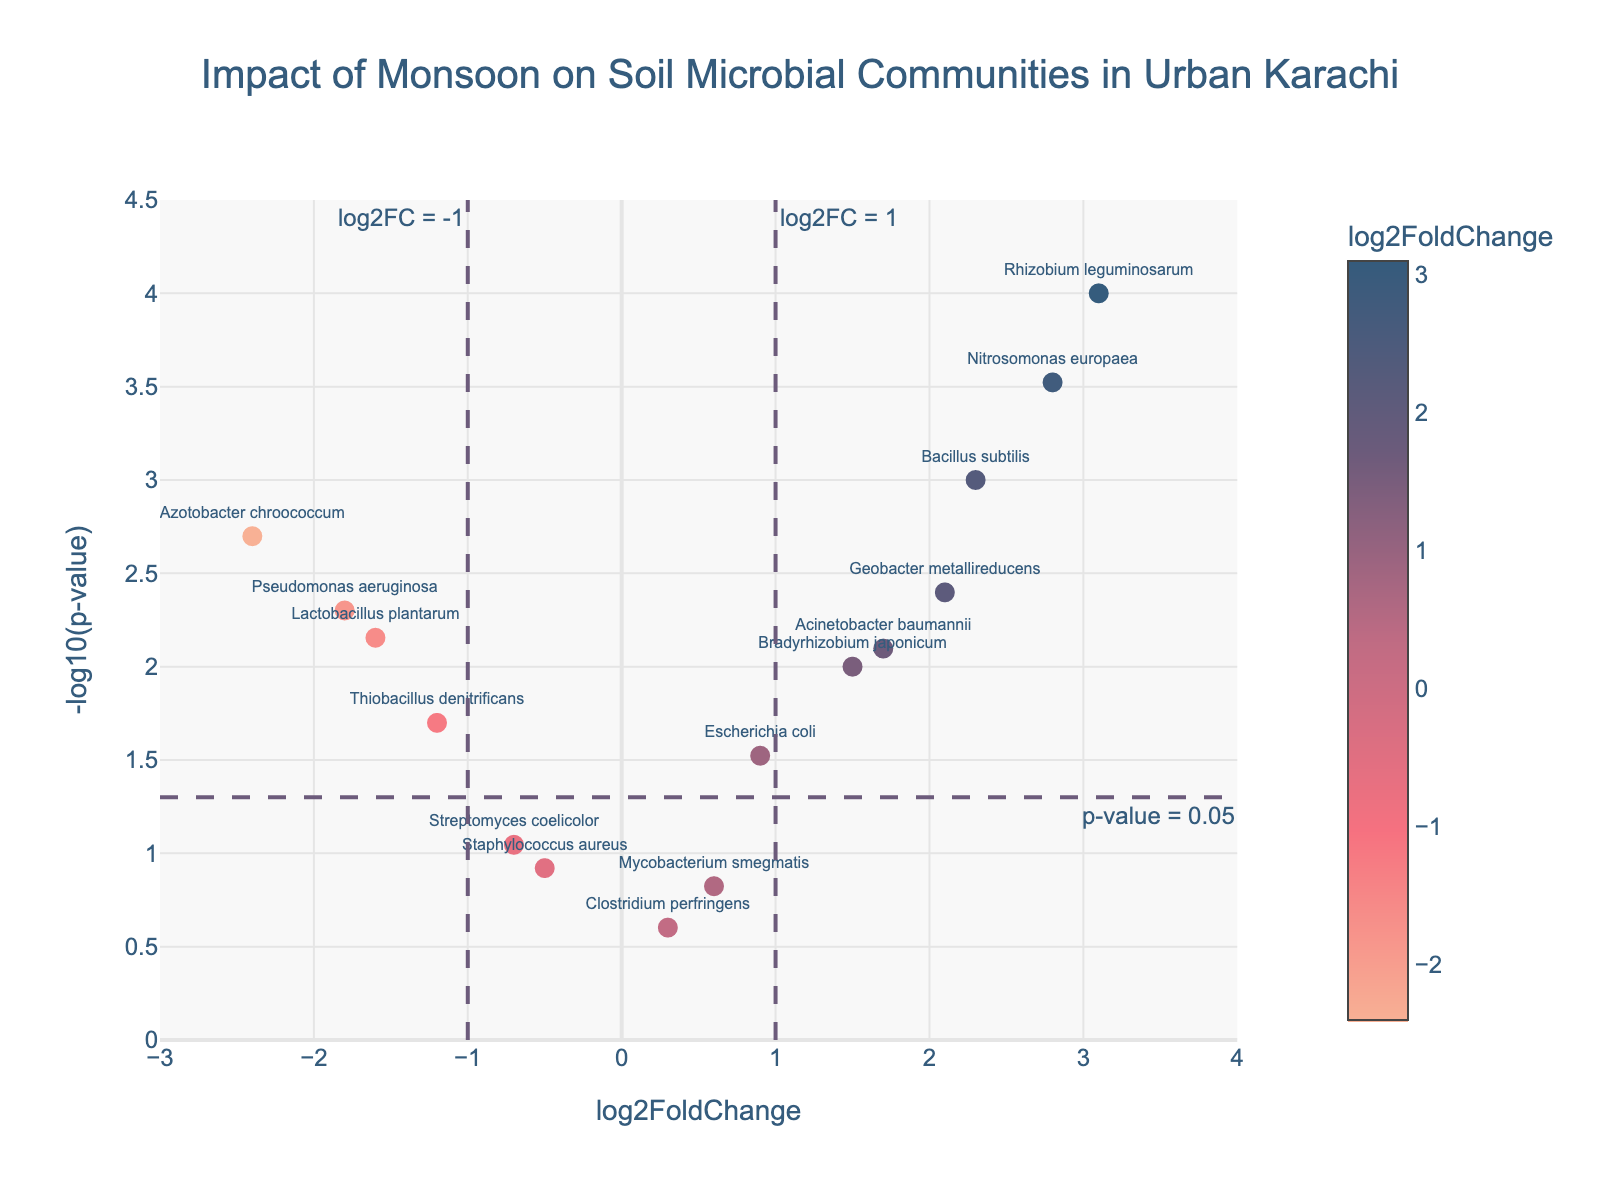What is the title of the plot? The title is displayed prominently at the top of the figure. It reads: "Impact of Monsoon on Soil Microbial Communities in Urban Karachi".
Answer: Impact of Monsoon on Soil Microbial Communities in Urban Karachi What does the x-axis represent in the plot? The x-axis is labeled at the bottom of the figure, which indicates that it represents "log2FoldChange".
Answer: log2FoldChange Which color in the plot represents the highest log2FoldChange? The color scale bar on the right side of the figure shows that darker shades represent higher log2FoldChange.
Answer: Darker shades represent higher log2FoldChange How many microbes have a log2FoldChange above 2? By inspecting the x-axis and counting the markers, we can see there are 4 microbes with log2FoldChange above 2.
Answer: 4 Which microbe has the highest -log10(p-value)? The topmost point on the y-axis represents the highest -log10(p-value), which is Rhizobium leguminosarum.
Answer: Rhizobium leguminosarum What is the log2FoldChange and p-value for Pseudomonas aeruginosa? Hovering over the relevant data point, the hover text shows "Pseudomonas aeruginosa<br>log2FC: -1.80<br>p-value: 0.0050".
Answer: log2FC: -1.80, p-value: 0.005 Which microbe shows a significant change with a p-value below 0.05 and a log2FoldChange greater than 1? Inspect the figure for data points with a y value above the dashed line corresponding to -log10(p-value) = 0.05 and x value greater than 1, which identifies Nitrosomonas europaea.
Answer: Nitrosomonas europaea What threshold values are indicated by dashed lines in the plot? The dashed lines mark threshold values at log2FC = 1 and log2FC = -1 on the x-axis and p-value = 0.05 on the y-axis.
Answer: log2FC = 1, log2FC = -1, p-value = 0.05 How many data points are considered not significant based on the threshold lines? Data points below the p-value threshold line (dashed line) are considered not significant. Count the number of such points. There are 6.
Answer: 6 Which data point has the lowest log2FoldChange but is significant? The leftmost point above the dashed threshold line for p-value represents the lowest significant log2FoldChange, which is Azotobacter chroococcum.
Answer: Azotobacter chroococcum 